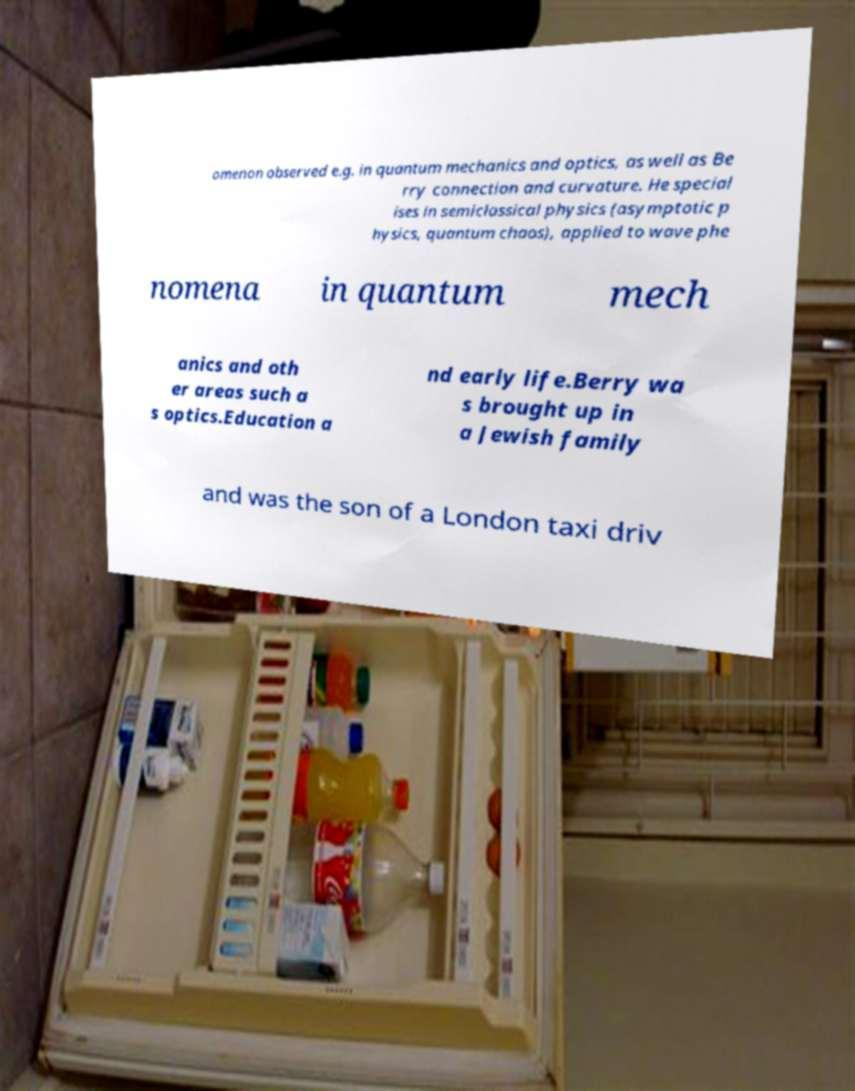Please read and relay the text visible in this image. What does it say? omenon observed e.g. in quantum mechanics and optics, as well as Be rry connection and curvature. He special ises in semiclassical physics (asymptotic p hysics, quantum chaos), applied to wave phe nomena in quantum mech anics and oth er areas such a s optics.Education a nd early life.Berry wa s brought up in a Jewish family and was the son of a London taxi driv 